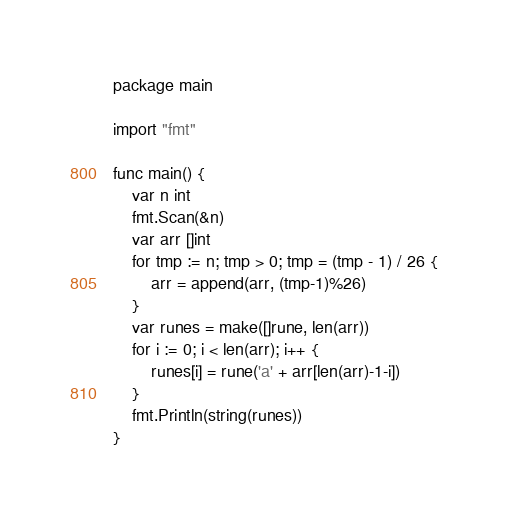Convert code to text. <code><loc_0><loc_0><loc_500><loc_500><_Go_>package main

import "fmt"

func main() {
	var n int
	fmt.Scan(&n)
	var arr []int
	for tmp := n; tmp > 0; tmp = (tmp - 1) / 26 {
		arr = append(arr, (tmp-1)%26)
	}
	var runes = make([]rune, len(arr))
	for i := 0; i < len(arr); i++ {
		runes[i] = rune('a' + arr[len(arr)-1-i])
	}
	fmt.Println(string(runes))
}
</code> 